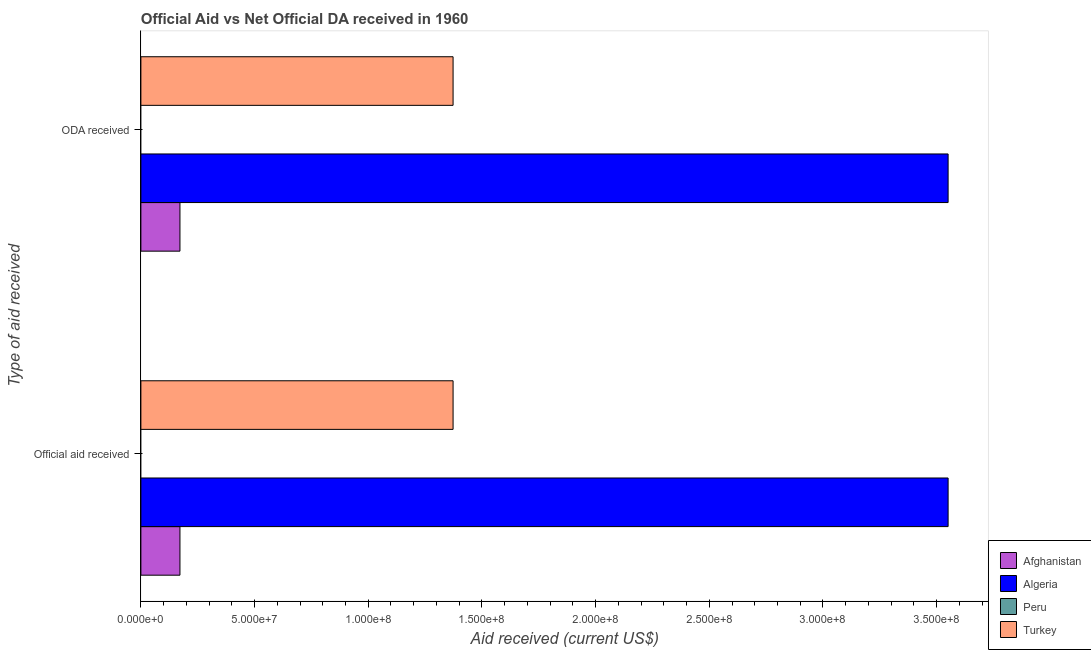How many different coloured bars are there?
Ensure brevity in your answer.  3. What is the label of the 1st group of bars from the top?
Provide a succinct answer. ODA received. What is the official aid received in Turkey?
Give a very brief answer. 1.37e+08. Across all countries, what is the maximum oda received?
Your answer should be very brief. 3.55e+08. Across all countries, what is the minimum oda received?
Give a very brief answer. 0. In which country was the oda received maximum?
Your answer should be compact. Algeria. What is the total official aid received in the graph?
Your answer should be compact. 5.10e+08. What is the difference between the oda received in Turkey and that in Afghanistan?
Keep it short and to the point. 1.20e+08. What is the difference between the oda received in Afghanistan and the official aid received in Algeria?
Your answer should be compact. -3.38e+08. What is the average official aid received per country?
Your response must be concise. 1.27e+08. In how many countries, is the official aid received greater than 250000000 US$?
Your response must be concise. 1. What is the ratio of the official aid received in Afghanistan to that in Algeria?
Provide a short and direct response. 0.05. Is the official aid received in Algeria less than that in Turkey?
Give a very brief answer. No. How many bars are there?
Provide a short and direct response. 6. What is the difference between two consecutive major ticks on the X-axis?
Offer a very short reply. 5.00e+07. Are the values on the major ticks of X-axis written in scientific E-notation?
Provide a short and direct response. Yes. Does the graph contain any zero values?
Make the answer very short. Yes. Does the graph contain grids?
Your answer should be very brief. No. How many legend labels are there?
Make the answer very short. 4. How are the legend labels stacked?
Your response must be concise. Vertical. What is the title of the graph?
Give a very brief answer. Official Aid vs Net Official DA received in 1960 . What is the label or title of the X-axis?
Your answer should be compact. Aid received (current US$). What is the label or title of the Y-axis?
Provide a succinct answer. Type of aid received. What is the Aid received (current US$) of Afghanistan in Official aid received?
Give a very brief answer. 1.72e+07. What is the Aid received (current US$) in Algeria in Official aid received?
Make the answer very short. 3.55e+08. What is the Aid received (current US$) of Turkey in Official aid received?
Your response must be concise. 1.37e+08. What is the Aid received (current US$) of Afghanistan in ODA received?
Offer a terse response. 1.72e+07. What is the Aid received (current US$) of Algeria in ODA received?
Provide a succinct answer. 3.55e+08. What is the Aid received (current US$) of Turkey in ODA received?
Give a very brief answer. 1.37e+08. Across all Type of aid received, what is the maximum Aid received (current US$) in Afghanistan?
Ensure brevity in your answer.  1.72e+07. Across all Type of aid received, what is the maximum Aid received (current US$) in Algeria?
Offer a terse response. 3.55e+08. Across all Type of aid received, what is the maximum Aid received (current US$) of Turkey?
Your response must be concise. 1.37e+08. Across all Type of aid received, what is the minimum Aid received (current US$) in Afghanistan?
Give a very brief answer. 1.72e+07. Across all Type of aid received, what is the minimum Aid received (current US$) of Algeria?
Ensure brevity in your answer.  3.55e+08. Across all Type of aid received, what is the minimum Aid received (current US$) in Turkey?
Your answer should be compact. 1.37e+08. What is the total Aid received (current US$) of Afghanistan in the graph?
Your answer should be very brief. 3.44e+07. What is the total Aid received (current US$) in Algeria in the graph?
Provide a short and direct response. 7.10e+08. What is the total Aid received (current US$) of Peru in the graph?
Offer a terse response. 0. What is the total Aid received (current US$) of Turkey in the graph?
Keep it short and to the point. 2.75e+08. What is the difference between the Aid received (current US$) of Afghanistan in Official aid received and that in ODA received?
Keep it short and to the point. 0. What is the difference between the Aid received (current US$) in Algeria in Official aid received and that in ODA received?
Give a very brief answer. 0. What is the difference between the Aid received (current US$) of Turkey in Official aid received and that in ODA received?
Make the answer very short. 0. What is the difference between the Aid received (current US$) of Afghanistan in Official aid received and the Aid received (current US$) of Algeria in ODA received?
Ensure brevity in your answer.  -3.38e+08. What is the difference between the Aid received (current US$) in Afghanistan in Official aid received and the Aid received (current US$) in Turkey in ODA received?
Your response must be concise. -1.20e+08. What is the difference between the Aid received (current US$) in Algeria in Official aid received and the Aid received (current US$) in Turkey in ODA received?
Provide a succinct answer. 2.18e+08. What is the average Aid received (current US$) of Afghanistan per Type of aid received?
Make the answer very short. 1.72e+07. What is the average Aid received (current US$) of Algeria per Type of aid received?
Your response must be concise. 3.55e+08. What is the average Aid received (current US$) in Turkey per Type of aid received?
Provide a short and direct response. 1.37e+08. What is the difference between the Aid received (current US$) of Afghanistan and Aid received (current US$) of Algeria in Official aid received?
Give a very brief answer. -3.38e+08. What is the difference between the Aid received (current US$) in Afghanistan and Aid received (current US$) in Turkey in Official aid received?
Your response must be concise. -1.20e+08. What is the difference between the Aid received (current US$) in Algeria and Aid received (current US$) in Turkey in Official aid received?
Keep it short and to the point. 2.18e+08. What is the difference between the Aid received (current US$) of Afghanistan and Aid received (current US$) of Algeria in ODA received?
Offer a terse response. -3.38e+08. What is the difference between the Aid received (current US$) of Afghanistan and Aid received (current US$) of Turkey in ODA received?
Give a very brief answer. -1.20e+08. What is the difference between the Aid received (current US$) in Algeria and Aid received (current US$) in Turkey in ODA received?
Provide a succinct answer. 2.18e+08. What is the ratio of the Aid received (current US$) of Afghanistan in Official aid received to that in ODA received?
Your answer should be very brief. 1. What is the ratio of the Aid received (current US$) in Algeria in Official aid received to that in ODA received?
Provide a succinct answer. 1. What is the difference between the highest and the second highest Aid received (current US$) in Turkey?
Ensure brevity in your answer.  0. What is the difference between the highest and the lowest Aid received (current US$) in Algeria?
Offer a very short reply. 0. What is the difference between the highest and the lowest Aid received (current US$) of Turkey?
Keep it short and to the point. 0. 